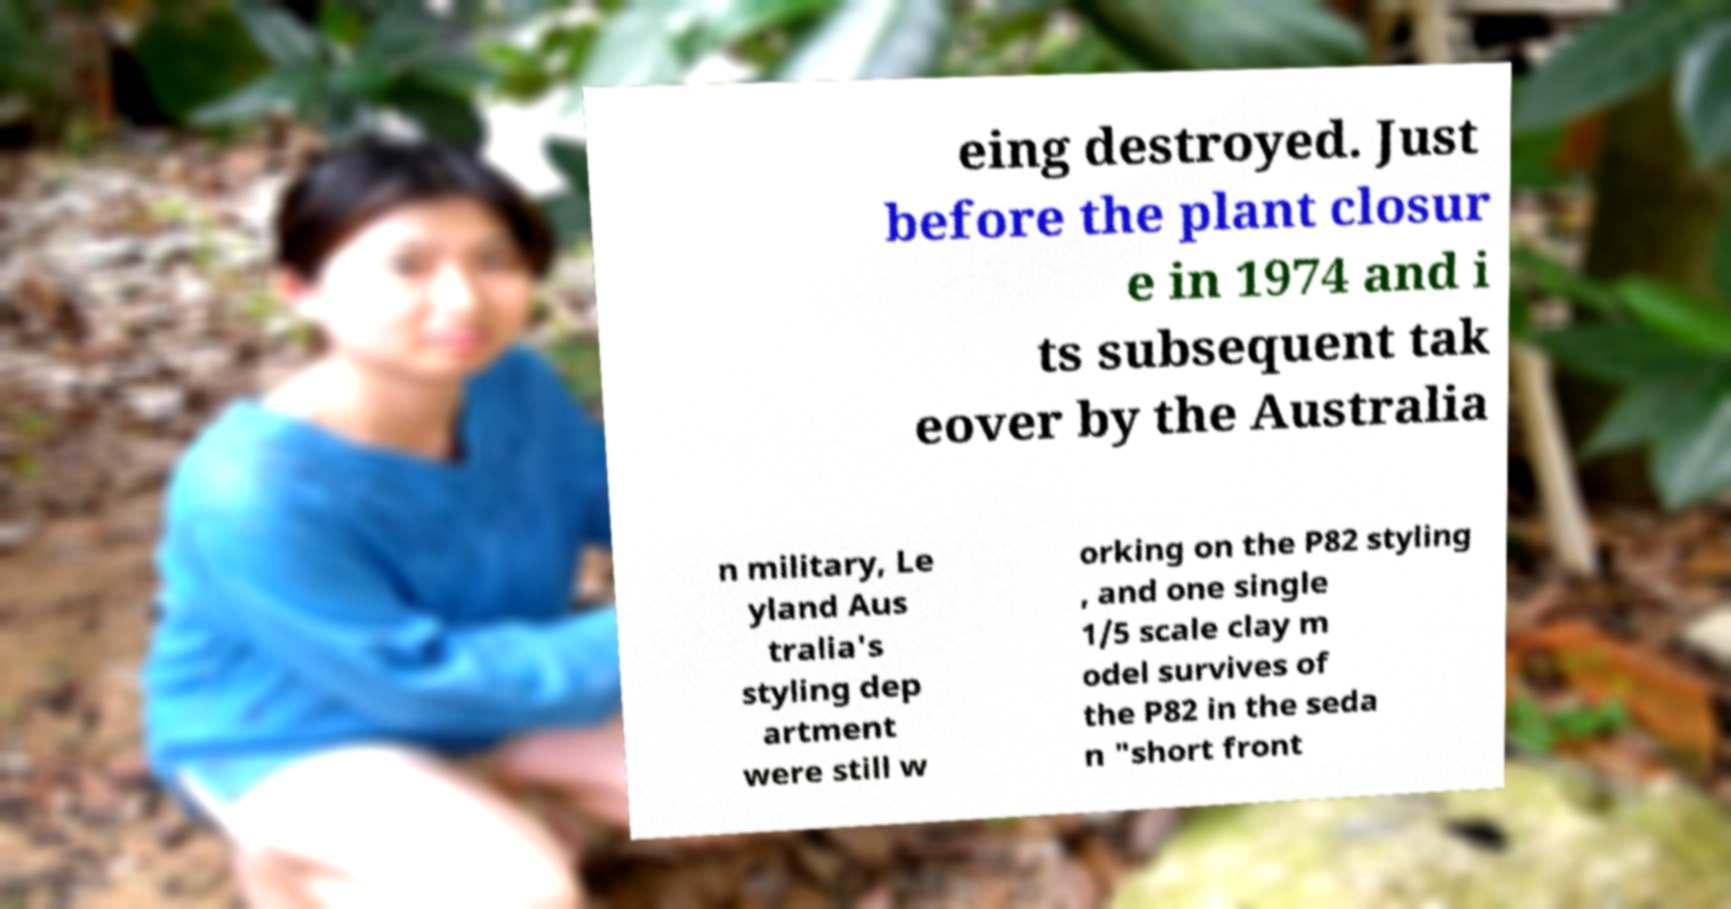Please read and relay the text visible in this image. What does it say? eing destroyed. Just before the plant closur e in 1974 and i ts subsequent tak eover by the Australia n military, Le yland Aus tralia's styling dep artment were still w orking on the P82 styling , and one single 1/5 scale clay m odel survives of the P82 in the seda n "short front 